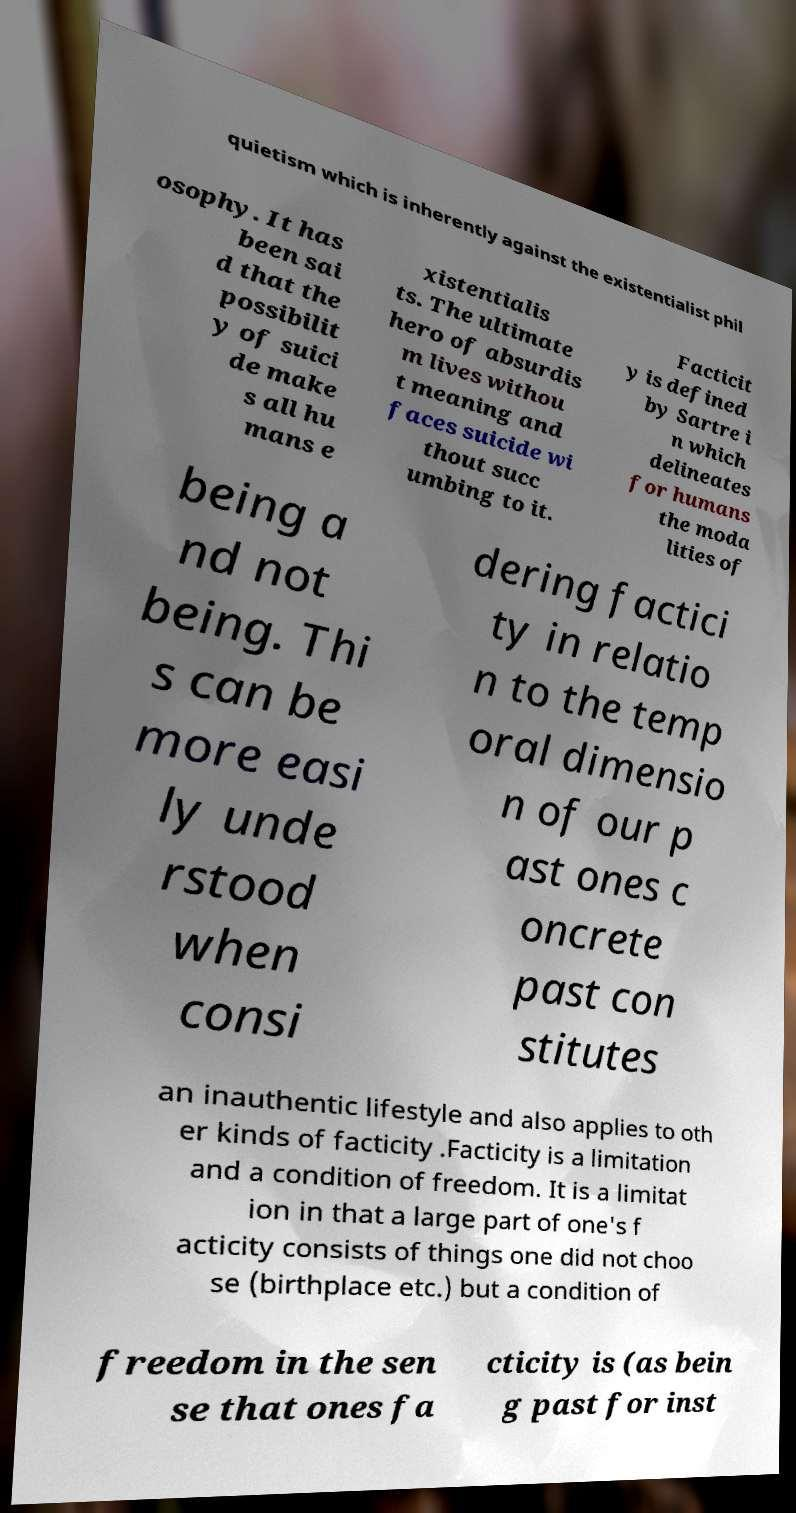Please identify and transcribe the text found in this image. quietism which is inherently against the existentialist phil osophy. It has been sai d that the possibilit y of suici de make s all hu mans e xistentialis ts. The ultimate hero of absurdis m lives withou t meaning and faces suicide wi thout succ umbing to it. Facticit y is defined by Sartre i n which delineates for humans the moda lities of being a nd not being. Thi s can be more easi ly unde rstood when consi dering factici ty in relatio n to the temp oral dimensio n of our p ast ones c oncrete past con stitutes an inauthentic lifestyle and also applies to oth er kinds of facticity .Facticity is a limitation and a condition of freedom. It is a limitat ion in that a large part of one's f acticity consists of things one did not choo se (birthplace etc.) but a condition of freedom in the sen se that ones fa cticity is (as bein g past for inst 